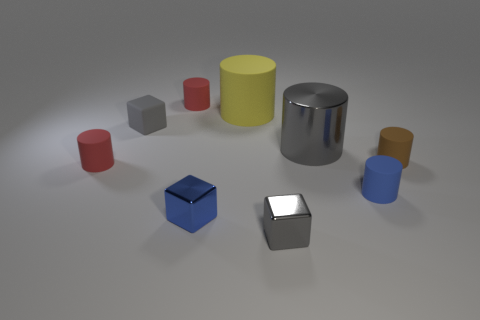Is the number of tiny matte things behind the big gray thing greater than the number of small gray rubber things?
Your answer should be compact. Yes. Does the shiny cylinder have the same color as the small rubber block?
Your answer should be very brief. Yes. What number of small blue rubber objects are the same shape as the small brown thing?
Your response must be concise. 1. There is a blue thing that is made of the same material as the small brown cylinder; what size is it?
Provide a short and direct response. Small. The small rubber cylinder that is on the right side of the blue cube and behind the tiny blue matte object is what color?
Give a very brief answer. Brown. How many metallic cylinders are the same size as the gray matte block?
Your answer should be compact. 0. There is a metallic cylinder that is the same color as the tiny rubber block; what size is it?
Offer a very short reply. Large. There is a gray thing that is both on the right side of the blue shiny block and behind the brown matte cylinder; what is its size?
Provide a short and direct response. Large. There is a tiny gray thing that is in front of the tiny red rubber cylinder that is in front of the large metallic thing; how many rubber objects are to the left of it?
Ensure brevity in your answer.  4. Is there a object that has the same color as the large shiny cylinder?
Provide a short and direct response. Yes. 